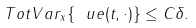<formula> <loc_0><loc_0><loc_500><loc_500>T o t V a r _ { x } \{ \ u e ( t , \cdot ) \} \leq C \delta .</formula> 